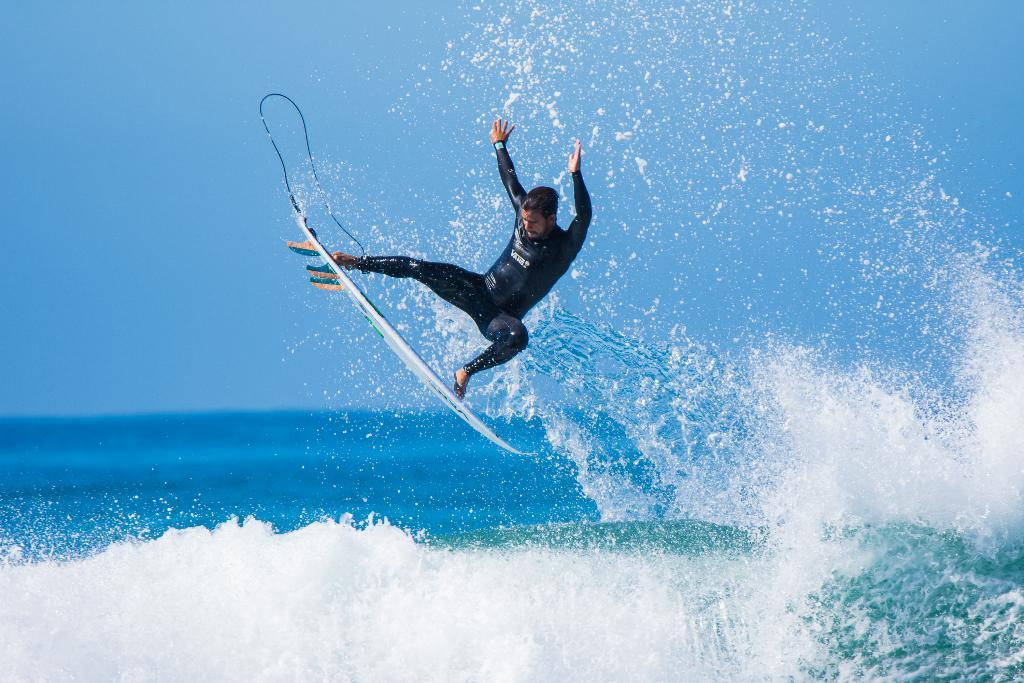What is the main subject of the image? There is a person in the image. What is the person wearing? The person is wearing a black dress. What activity is the person engaged in? The person is riding a white surfboard. Where is the surfboard located? The surfboard is near the tides of the ocean. What can be seen in the background of the image? There is a blue sky in the background of the image. Can you see any roses on the surfboard in the image? There are no roses visible on the surfboard in the image. Is there a porter carrying the person's belongings in the image? There is no porter present in the image. 